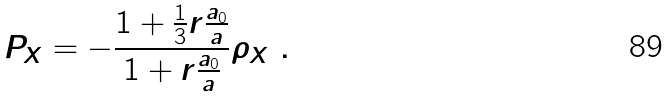<formula> <loc_0><loc_0><loc_500><loc_500>P _ { X } = - \frac { 1 + \frac { 1 } { 3 } r \frac { a _ { 0 } } { a } } { 1 + r \frac { a _ { 0 } } { a } } \rho _ { X } \ .</formula> 